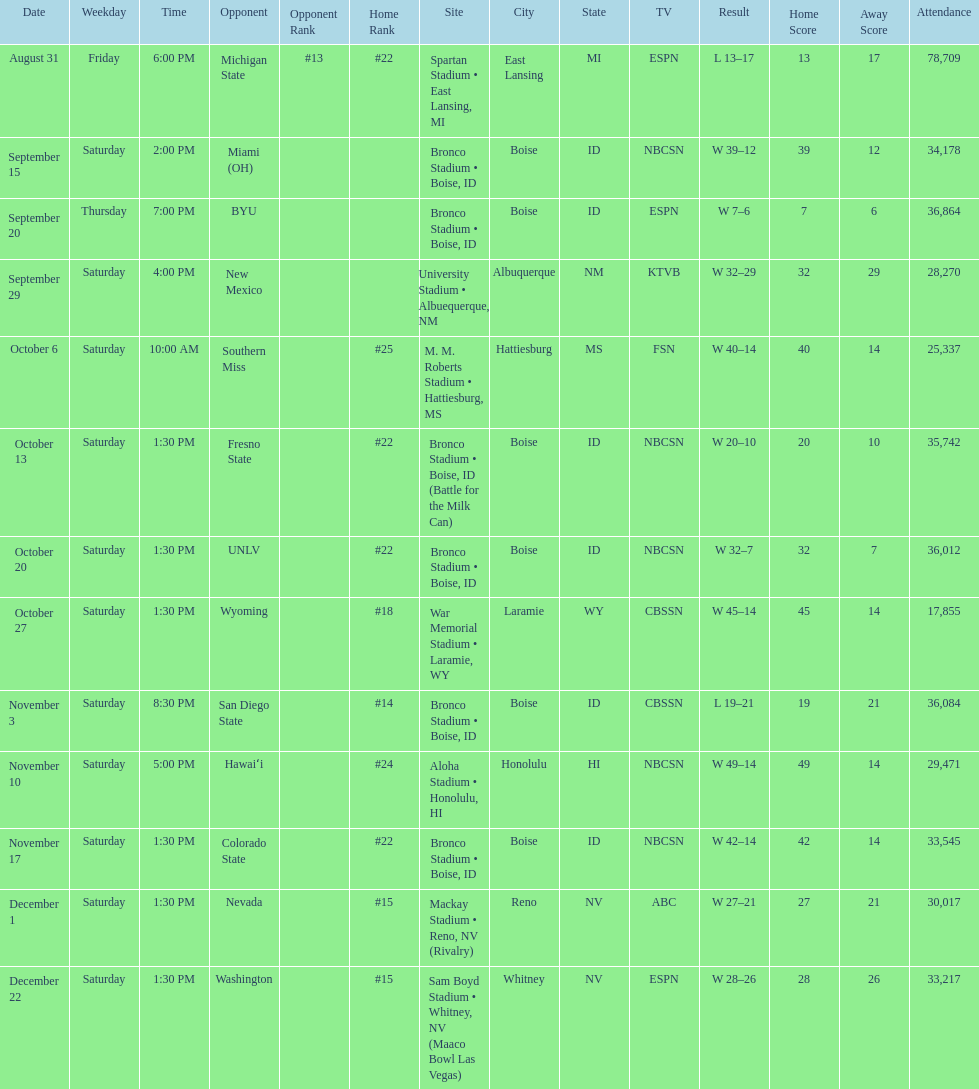Did the broncos on september 29th win by less than 5 points? Yes. 